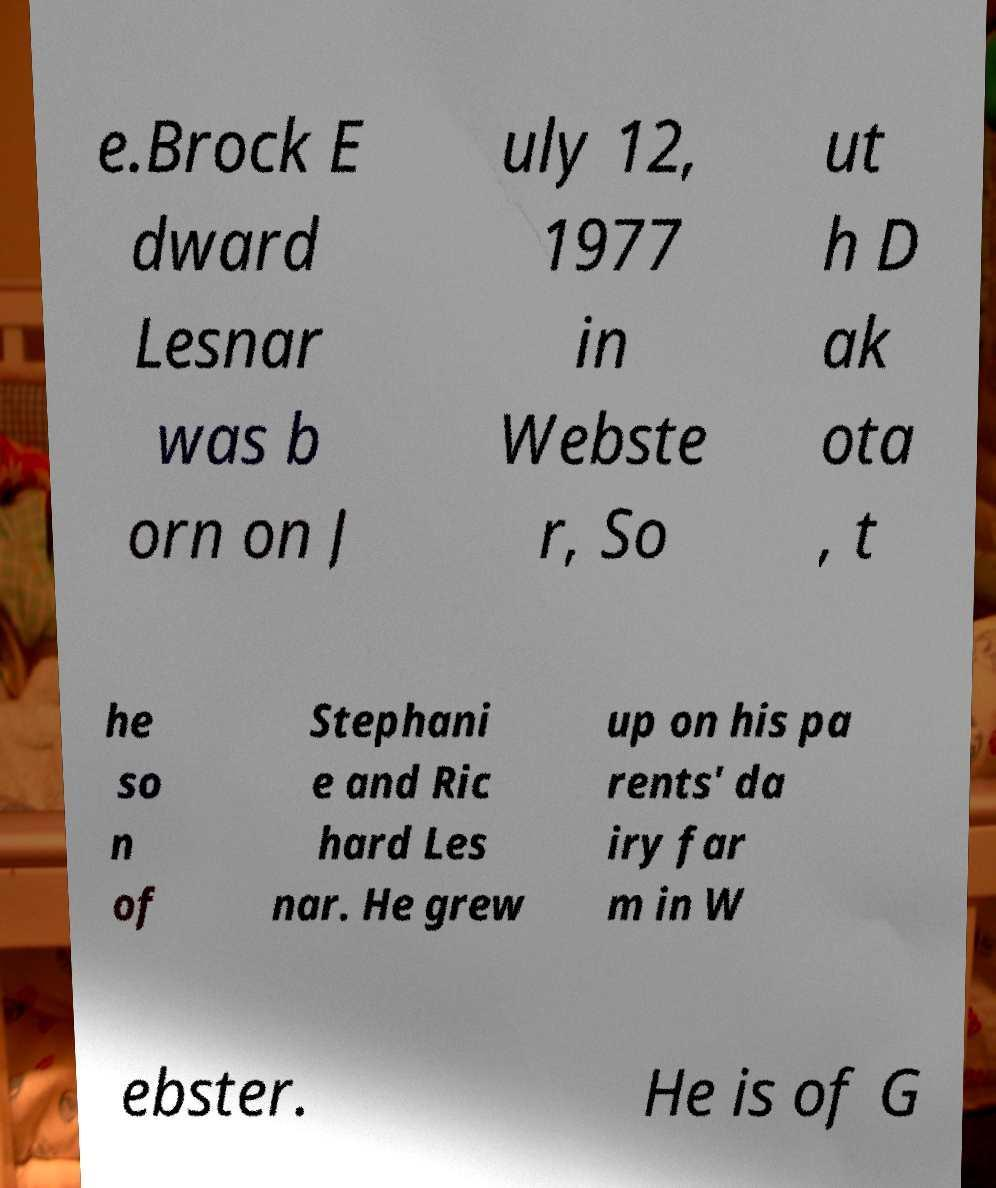Please read and relay the text visible in this image. What does it say? e.Brock E dward Lesnar was b orn on J uly 12, 1977 in Webste r, So ut h D ak ota , t he so n of Stephani e and Ric hard Les nar. He grew up on his pa rents' da iry far m in W ebster. He is of G 